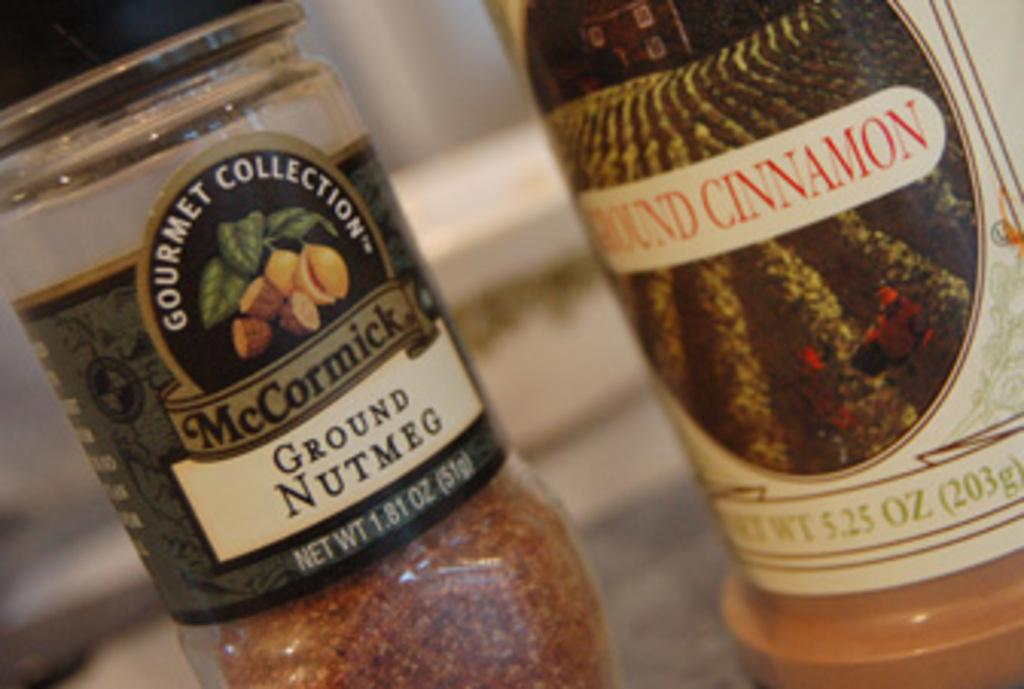<image>
Create a compact narrative representing the image presented. close ups of Ground Nutmeg and Ground Cinnamon 